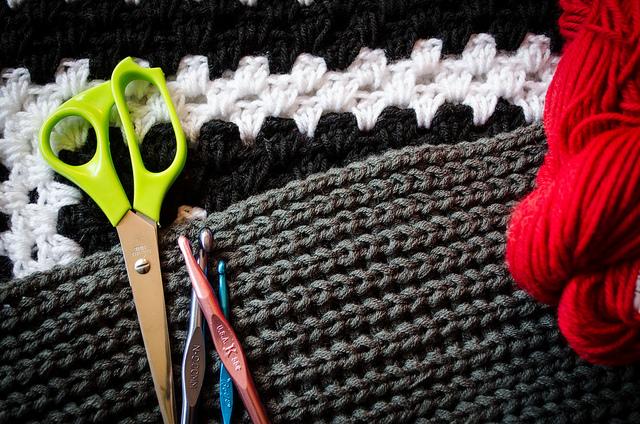What type of work is being done?
Be succinct. Crochet. Are they knitted?
Answer briefly. Yes. What type of hooks are those?
Answer briefly. Crochet. 